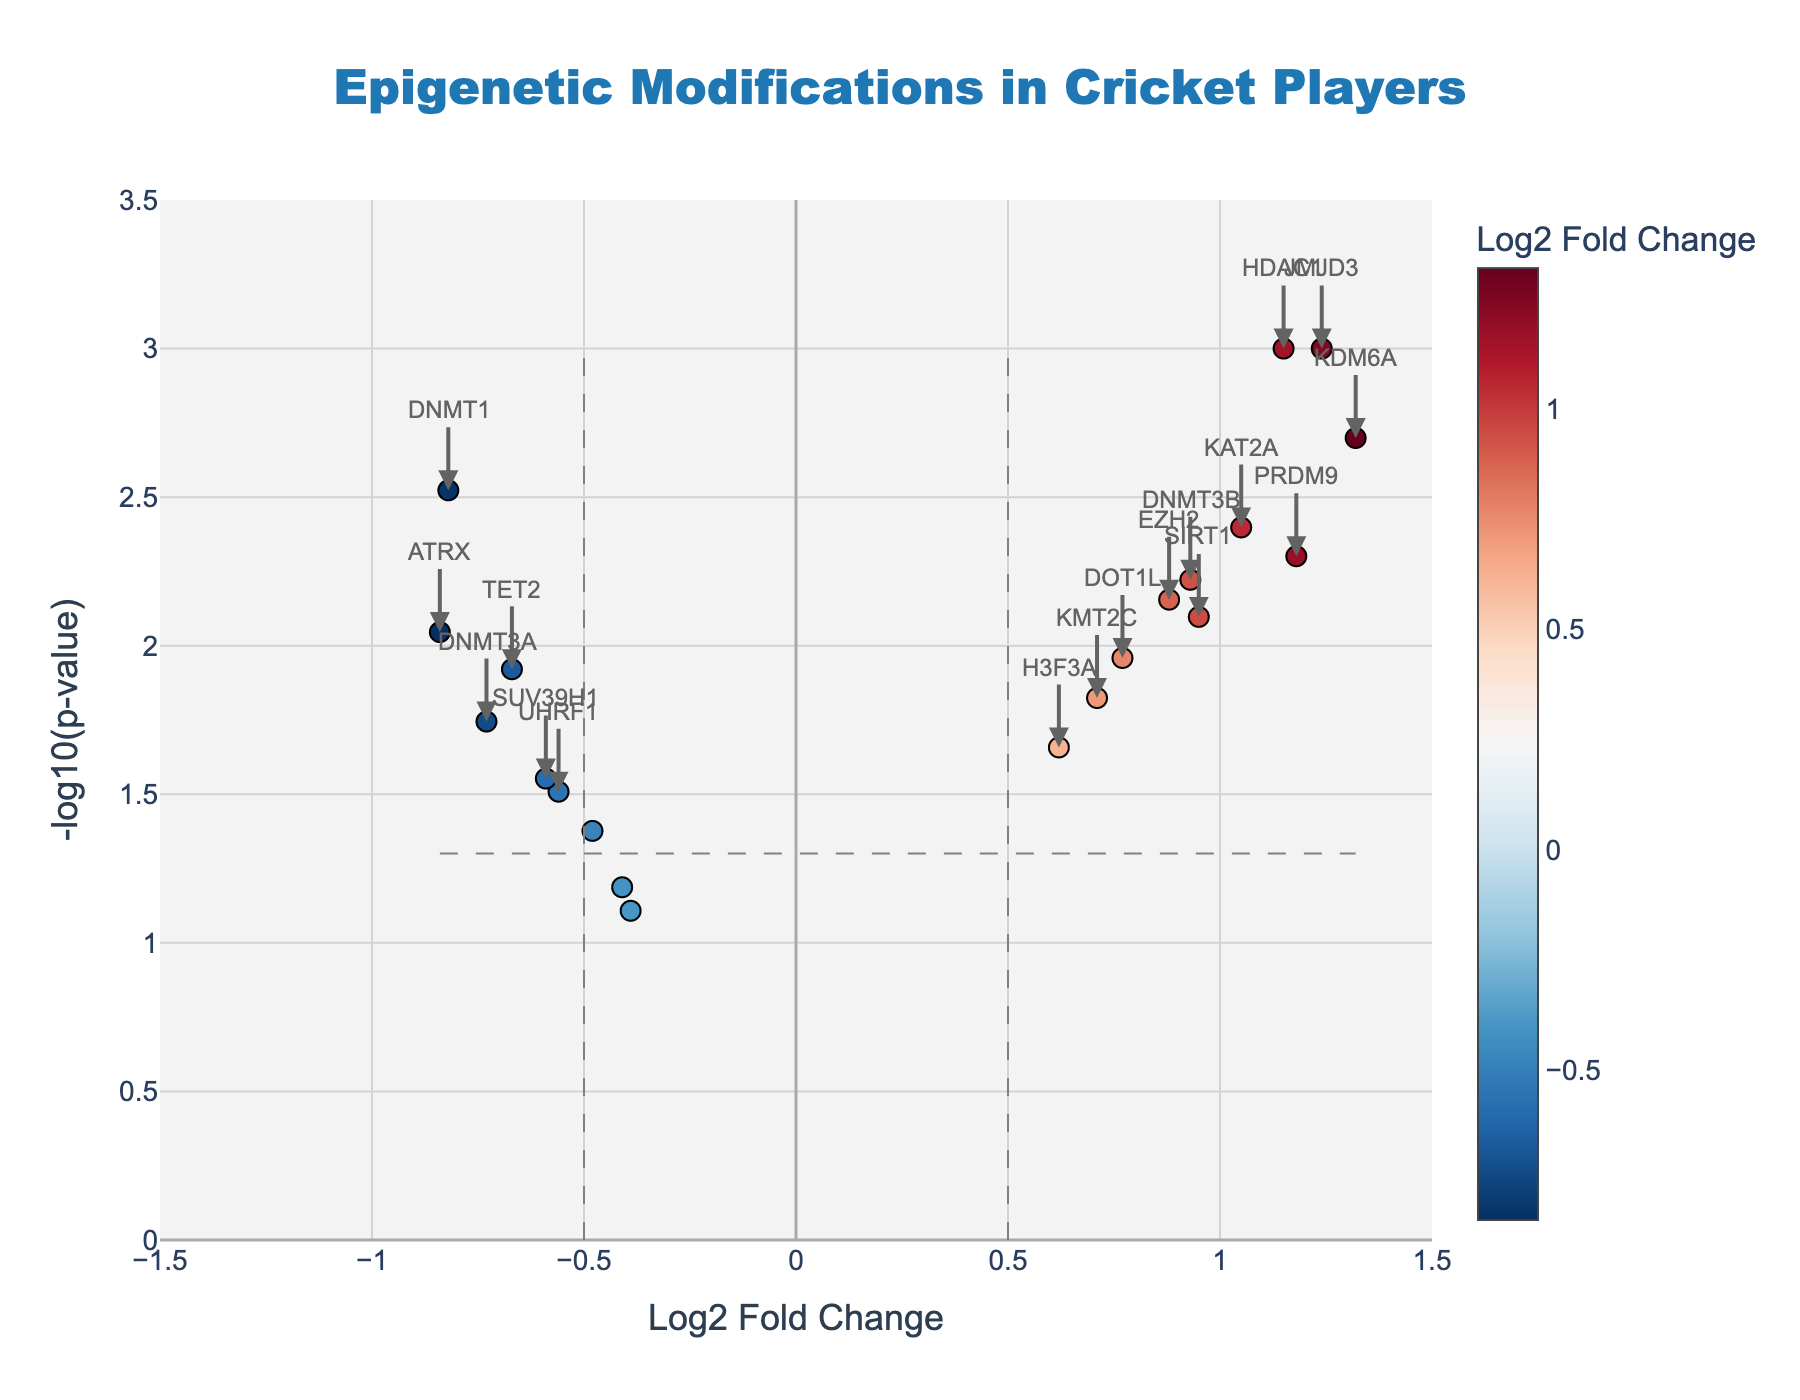How many genes have statistically significant changes? A gene is statistically significant if its p-value is less than the 0.05 threshold. We count the points that are above the horizontal dashed grey line at -log10(0.05) ≈ 1.3.
Answer: 15 Which gene has the highest Log2 Fold Change? Look for the point with the maximum value on the x-axis.
Answer: KDM6A What is the Log2 Fold Change and p-value for the gene SIRT1? Locate SIRT1 in the plot and read its Log2 Fold Change on the x-axis and p-value on the y-axis (convert from -log10).
Answer: Log2 Fold Change: 0.95, P-value: 0.008 Which gene has the lowest p-value? The gene with the highest value on the y-axis (-log10(p-value)) has the lowest raw p-value.
Answer: HDAC1 and JMJD3 How many genes have a Log2 Fold Change greater than 0.5? Count the points located to the right of the dashed vertical grey line at 0.5.
Answer: 10 Which genes have both Log2 Fold Change greater than 0.5 and statistically significant p-values? Find genes to the right of the 0.5 threshold and above the -log10(0.05) line.
Answer: HDAC1, SIRT1, KDM6A, EZH2, H3F3A, KMT2C, PRDM9, DNMT3B, JMJD3, DOT1L Which genes exhibit a decrease in expression and are statistically significant? Locate points to the left of the -0.5 threshold and above the -log10(0.05) line on the plot. These genes have negative Log2 Fold Changes and significant p-values.
Answer: DNMT1, TET2, DNMT3A, ATRX Compare the Log2 Fold Changes of DNMT1 and DNMT3B. Which one is more extreme? Look at the x-axis positions. The gene farther from zero has the more extreme change.
Answer: DNMT1 What Log2 Fold Change threshold marks the separation between increased and decreased gene expression? Find the value where the direction of the Log2 Fold Change switches.
Answer: 0 Among the significant genes, which one has the smallest negative Log2 Fold Change? From the subset of significant genes with negative changes, find the one nearest to zero.
Answer: UHRF1 